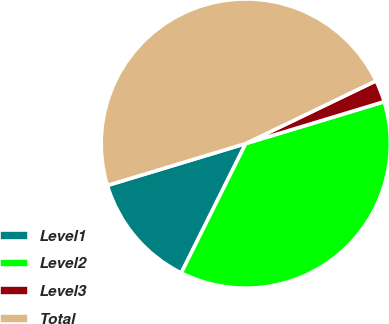<chart> <loc_0><loc_0><loc_500><loc_500><pie_chart><fcel>Level1<fcel>Level2<fcel>Level3<fcel>Total<nl><fcel>12.96%<fcel>37.04%<fcel>2.47%<fcel>47.53%<nl></chart> 